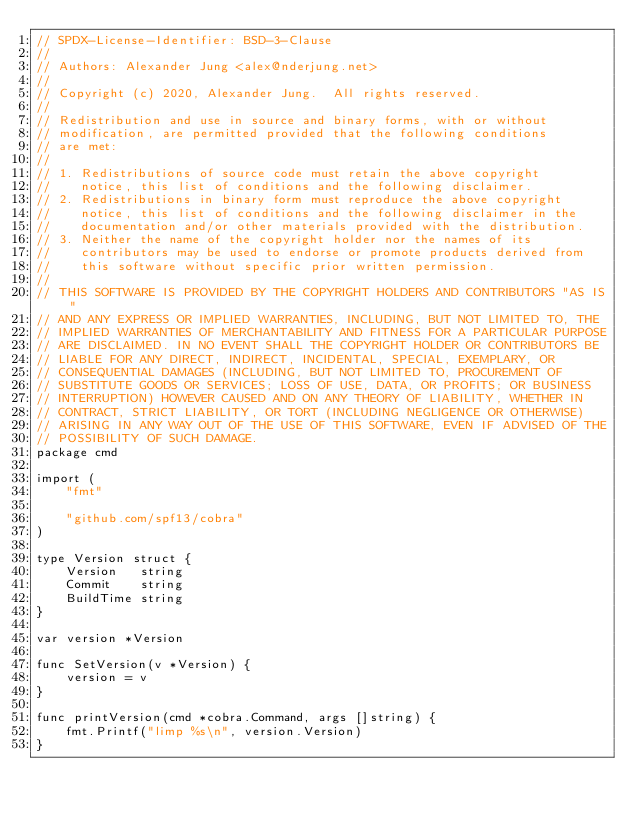<code> <loc_0><loc_0><loc_500><loc_500><_Go_>// SPDX-License-Identifier: BSD-3-Clause
//
// Authors: Alexander Jung <alex@nderjung.net>
//
// Copyright (c) 2020, Alexander Jung.  All rights reserved.
//
// Redistribution and use in source and binary forms, with or without
// modification, are permitted provided that the following conditions
// are met:
//
// 1. Redistributions of source code must retain the above copyright
//    notice, this list of conditions and the following disclaimer.
// 2. Redistributions in binary form must reproduce the above copyright
//    notice, this list of conditions and the following disclaimer in the
//    documentation and/or other materials provided with the distribution.
// 3. Neither the name of the copyright holder nor the names of its
//    contributors may be used to endorse or promote products derived from
//    this software without specific prior written permission.
//
// THIS SOFTWARE IS PROVIDED BY THE COPYRIGHT HOLDERS AND CONTRIBUTORS "AS IS"
// AND ANY EXPRESS OR IMPLIED WARRANTIES, INCLUDING, BUT NOT LIMITED TO, THE
// IMPLIED WARRANTIES OF MERCHANTABILITY AND FITNESS FOR A PARTICULAR PURPOSE
// ARE DISCLAIMED. IN NO EVENT SHALL THE COPYRIGHT HOLDER OR CONTRIBUTORS BE
// LIABLE FOR ANY DIRECT, INDIRECT, INCIDENTAL, SPECIAL, EXEMPLARY, OR
// CONSEQUENTIAL DAMAGES (INCLUDING, BUT NOT LIMITED TO, PROCUREMENT OF
// SUBSTITUTE GOODS OR SERVICES; LOSS OF USE, DATA, OR PROFITS; OR BUSINESS
// INTERRUPTION) HOWEVER CAUSED AND ON ANY THEORY OF LIABILITY, WHETHER IN
// CONTRACT, STRICT LIABILITY, OR TORT (INCLUDING NEGLIGENCE OR OTHERWISE)
// ARISING IN ANY WAY OUT OF THE USE OF THIS SOFTWARE, EVEN IF ADVISED OF THE
// POSSIBILITY OF SUCH DAMAGE.
package cmd

import (
	"fmt"

	"github.com/spf13/cobra"
)

type Version struct {
	Version   string
	Commit    string
	BuildTime string
}

var version *Version

func SetVersion(v *Version) {
	version = v
}

func printVersion(cmd *cobra.Command, args []string) {
	fmt.Printf("limp %s\n", version.Version)
}
</code> 